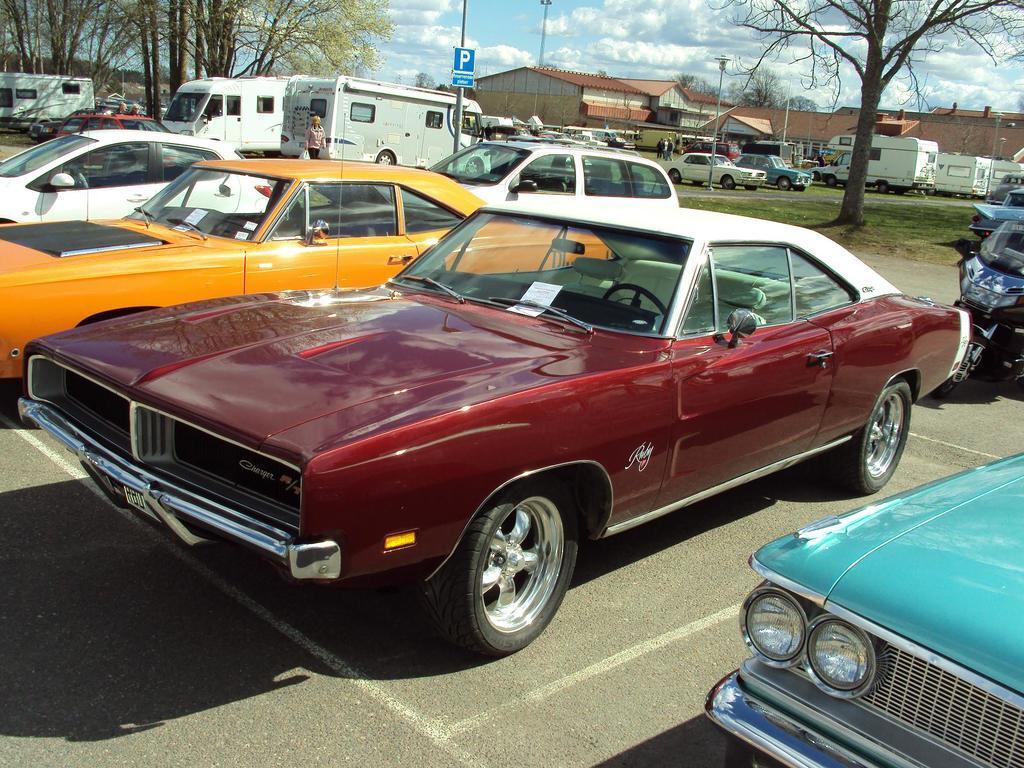How would you summarize this image in a sentence or two? In this picture I can see vehicles, there are group of people standing, there are poles, boards, lights, there are houses, trees, and in the background there is sky. 